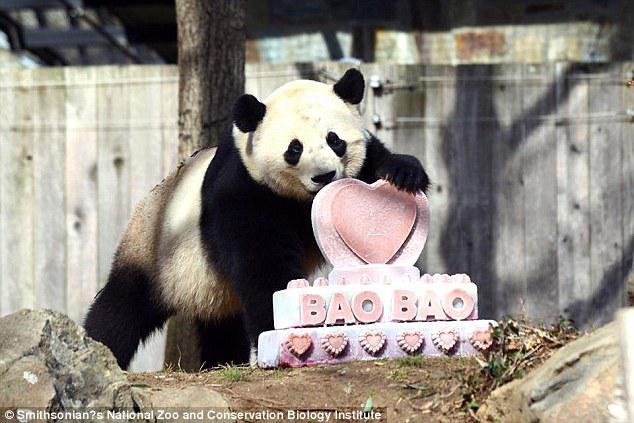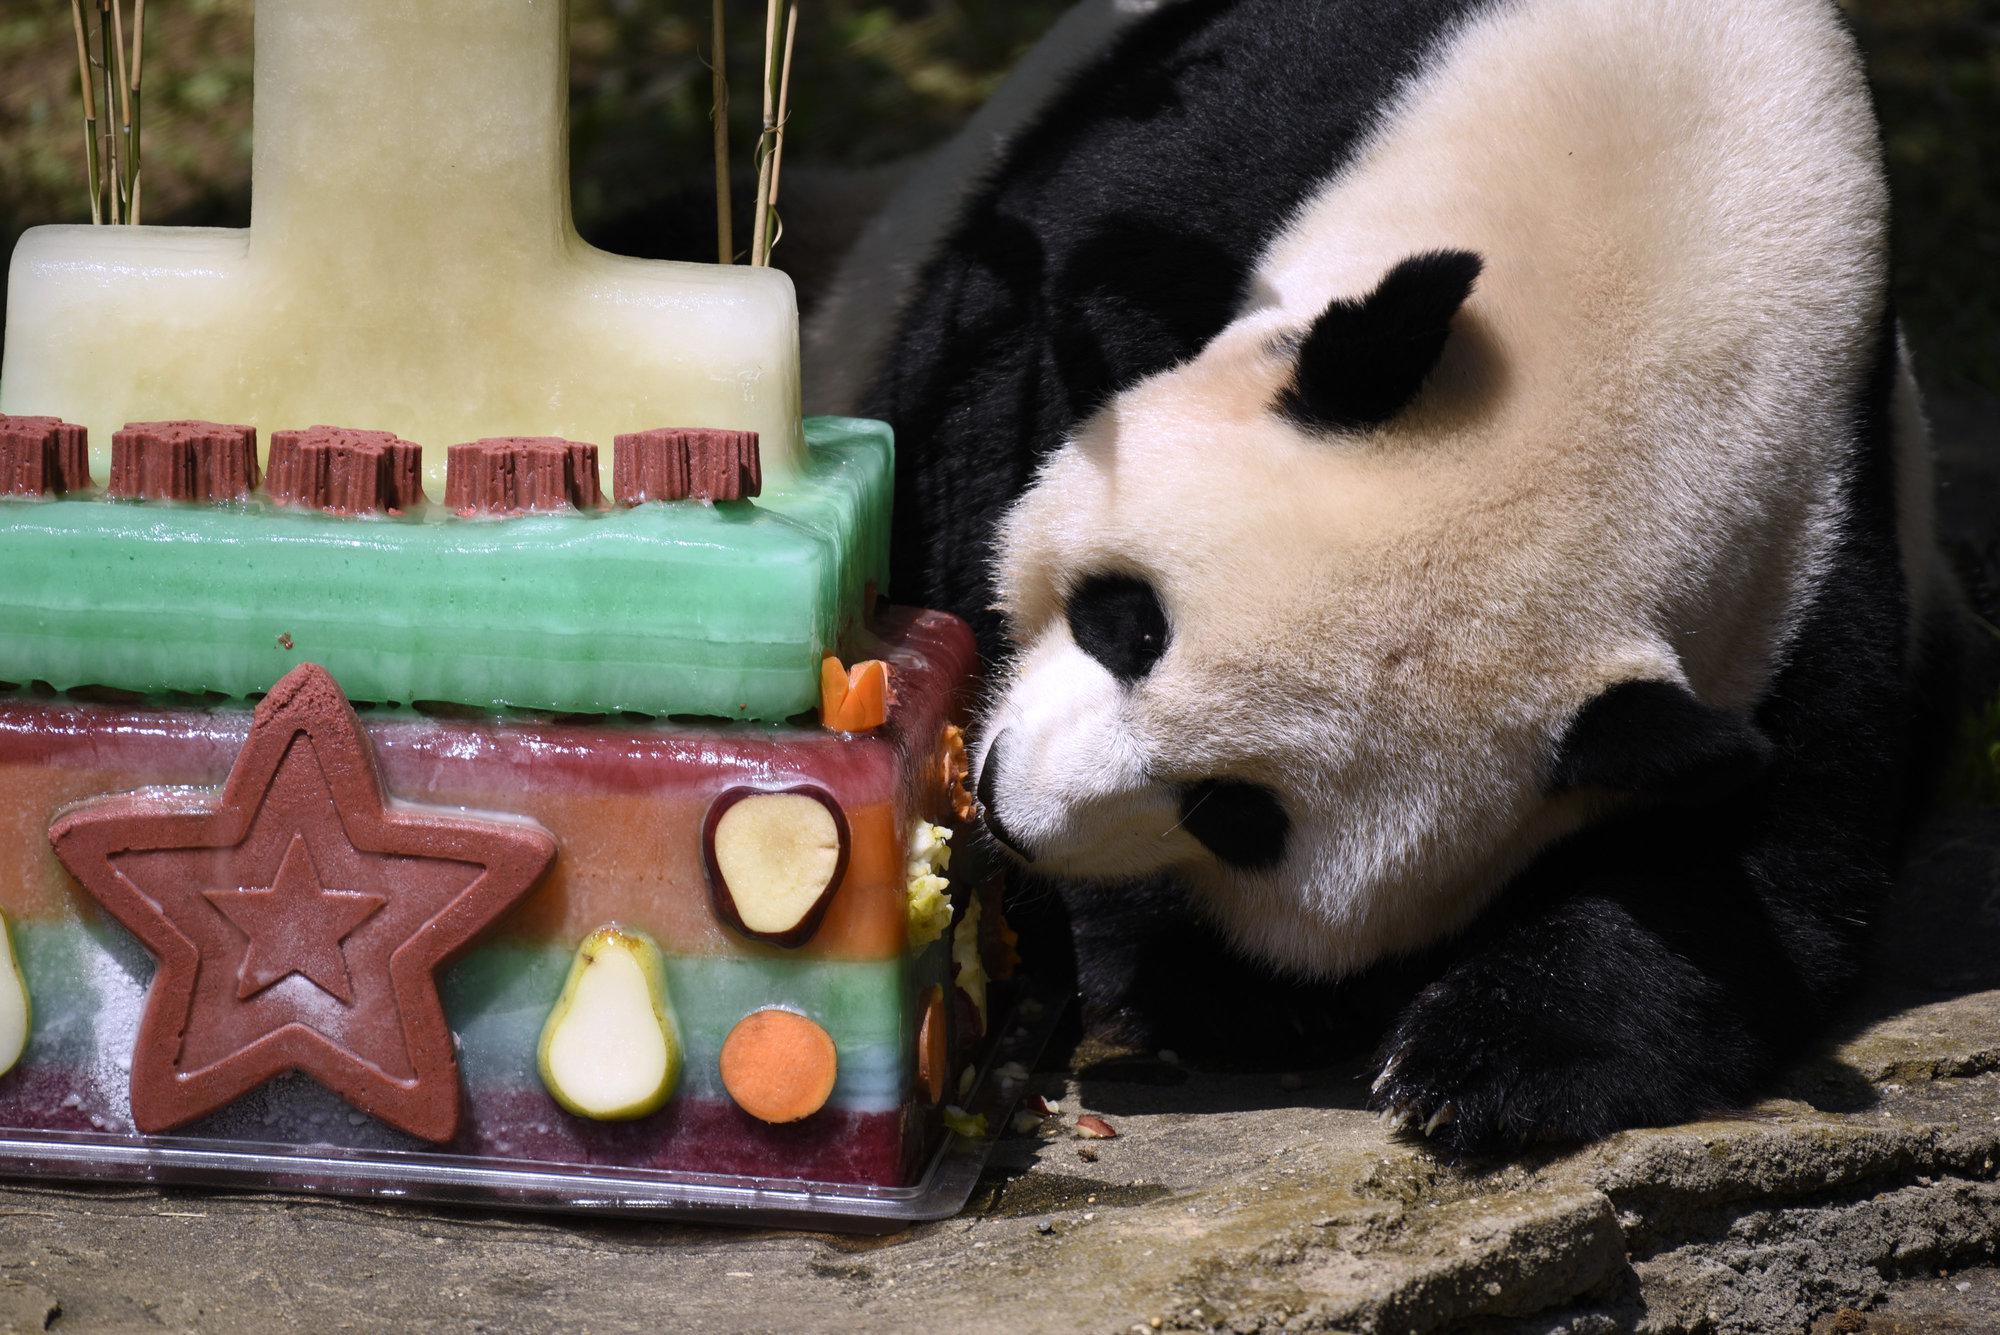The first image is the image on the left, the second image is the image on the right. Examine the images to the left and right. Is the description "The panda on the left is shown with some green bamboo." accurate? Answer yes or no. No. The first image is the image on the left, the second image is the image on the right. For the images displayed, is the sentence "Each image contains a single panda, and one image shows a panda reaching one paw toward a manmade object with a squarish base." factually correct? Answer yes or no. Yes. 